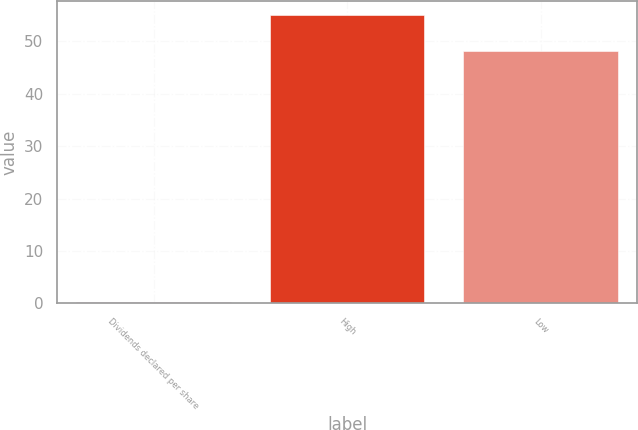Convert chart to OTSL. <chart><loc_0><loc_0><loc_500><loc_500><bar_chart><fcel>Dividends declared per share<fcel>High<fcel>Low<nl><fcel>0.18<fcel>55<fcel>48.13<nl></chart> 